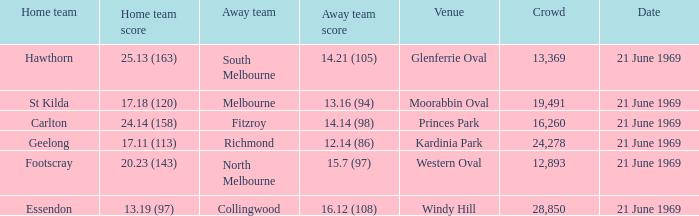When did an away team score 15.7 (97)? 21 June 1969. 